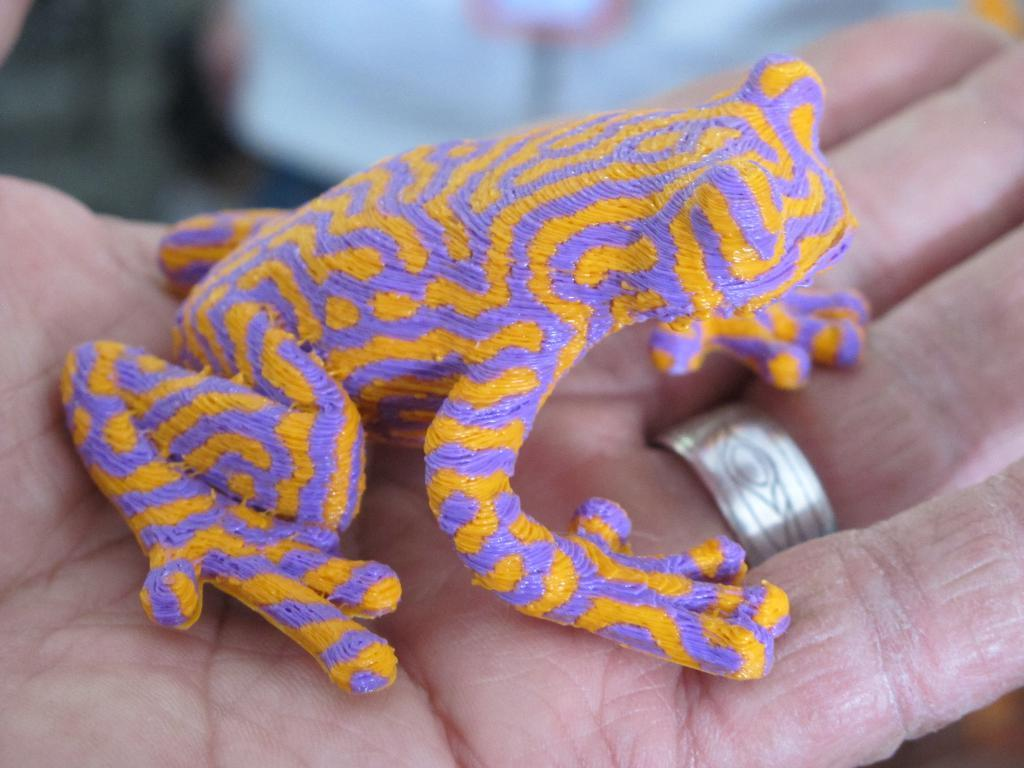What object is present on a hand in the image? There is a toy on a hand in the image. Can you describe the toy's appearance? The toy has yellow and purple colors. What other accessory can be seen on a finger in the image? There is a ring on a finger in the image. How would you describe the background of the image? The background of the image is blurred. How do the sisters react to the toy on the floor in the image? There are no sisters present in the image, and the toy is on a hand, not on the floor. 